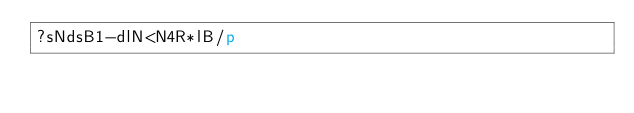<code> <loc_0><loc_0><loc_500><loc_500><_dc_>?sNdsB1-dlN<N4R*lB/p</code> 